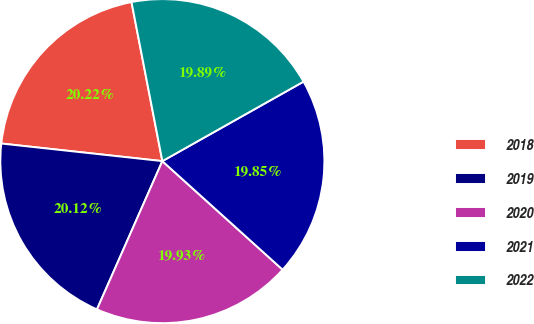Convert chart. <chart><loc_0><loc_0><loc_500><loc_500><pie_chart><fcel>2018<fcel>2019<fcel>2020<fcel>2021<fcel>2022<nl><fcel>20.22%<fcel>20.12%<fcel>19.93%<fcel>19.85%<fcel>19.89%<nl></chart> 